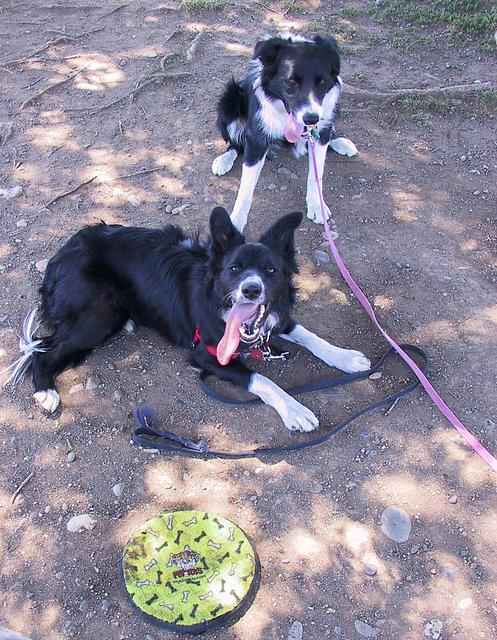What color is the lead to the dog standing to the rear side of the black dog? pink 